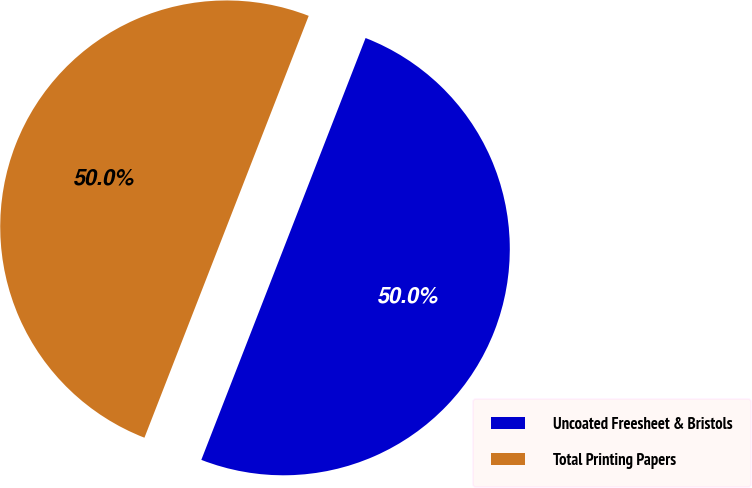Convert chart. <chart><loc_0><loc_0><loc_500><loc_500><pie_chart><fcel>Uncoated Freesheet & Bristols<fcel>Total Printing Papers<nl><fcel>50.0%<fcel>50.0%<nl></chart> 